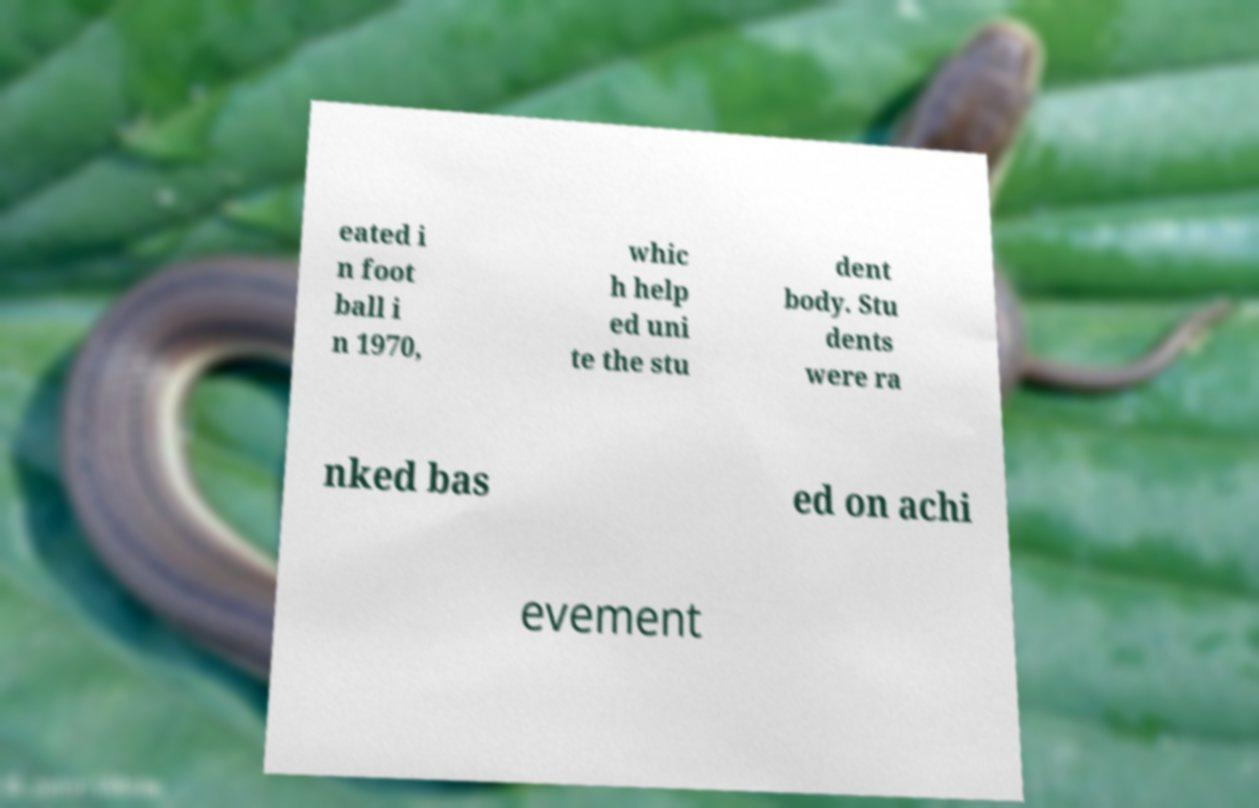For documentation purposes, I need the text within this image transcribed. Could you provide that? eated i n foot ball i n 1970, whic h help ed uni te the stu dent body. Stu dents were ra nked bas ed on achi evement 